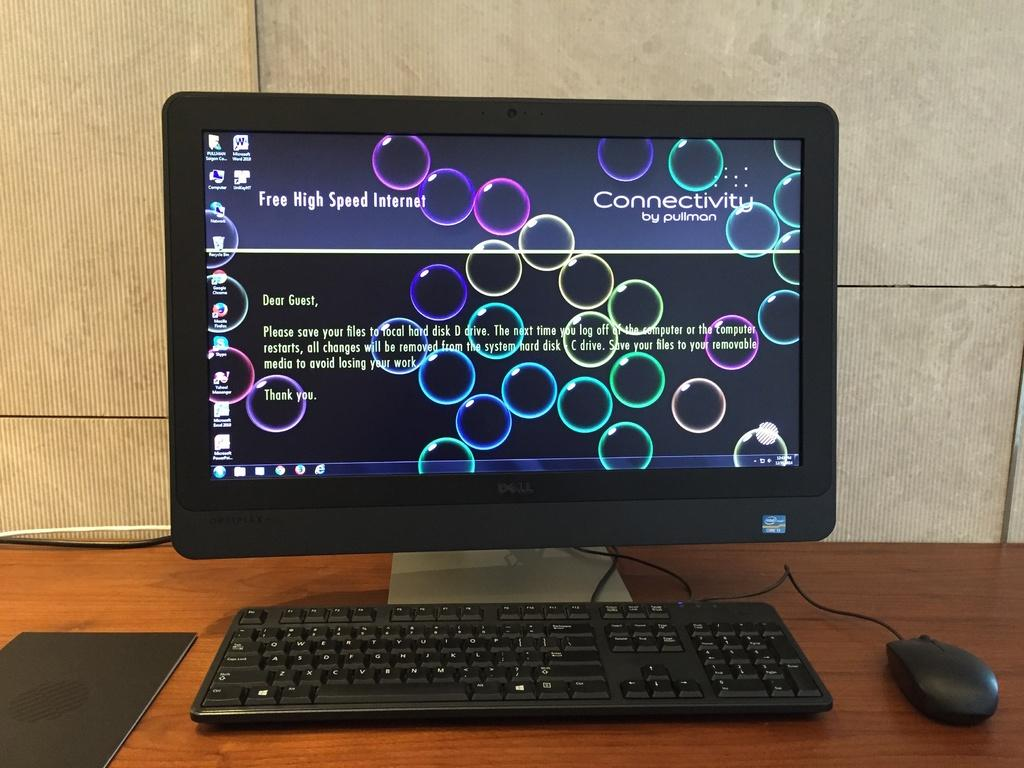Provide a one-sentence caption for the provided image. A computer with an Intel Core i3 processor is on a screen about Connectivity. 